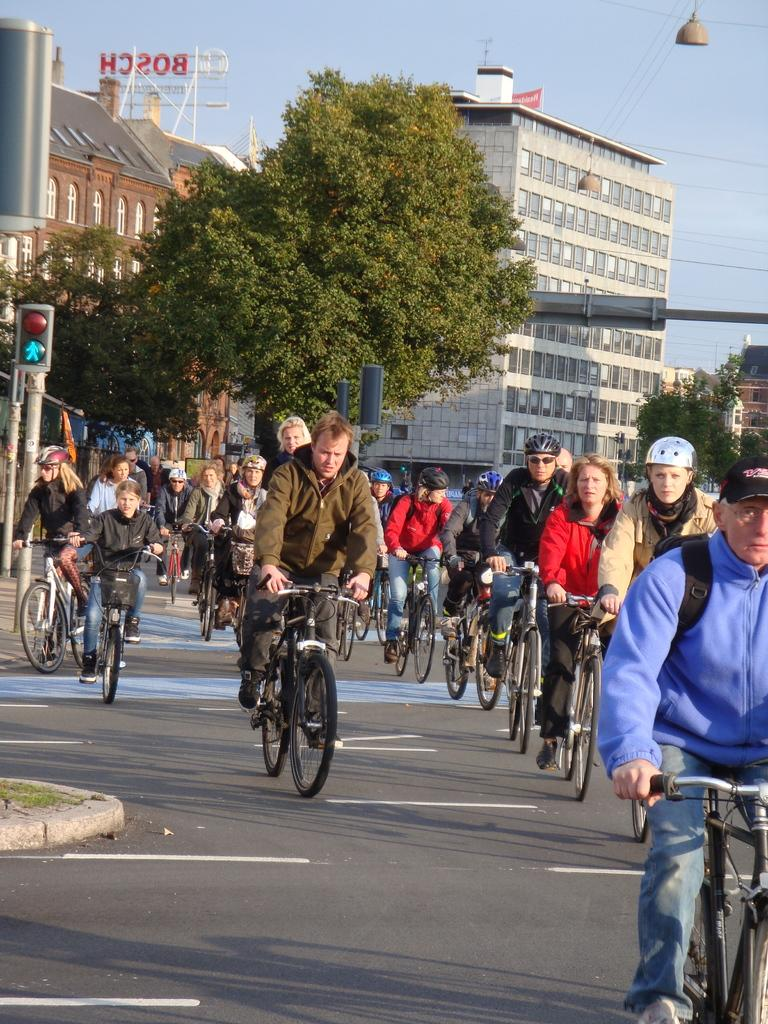What are the people in the image doing? The people in the image are cycling. Where are the people cycling? The people are on a road. What can be seen in the background of the image? There are poles, trees, buildings, and the sky visible in the background of the image. How many sisters are washing their bikes in the image? There are no sisters or bikes being washed in the image; it features people cycling on a road. 